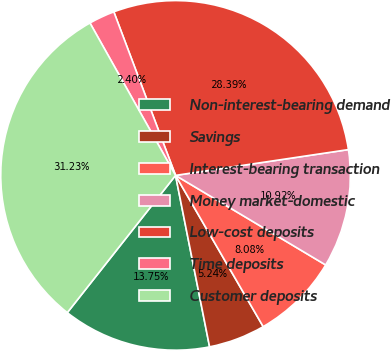<chart> <loc_0><loc_0><loc_500><loc_500><pie_chart><fcel>Non-interest-bearing demand<fcel>Savings<fcel>Interest-bearing transaction<fcel>Money market-domestic<fcel>Low-cost deposits<fcel>Time deposits<fcel>Customer deposits<nl><fcel>13.75%<fcel>5.24%<fcel>8.08%<fcel>10.92%<fcel>28.39%<fcel>2.4%<fcel>31.23%<nl></chart> 